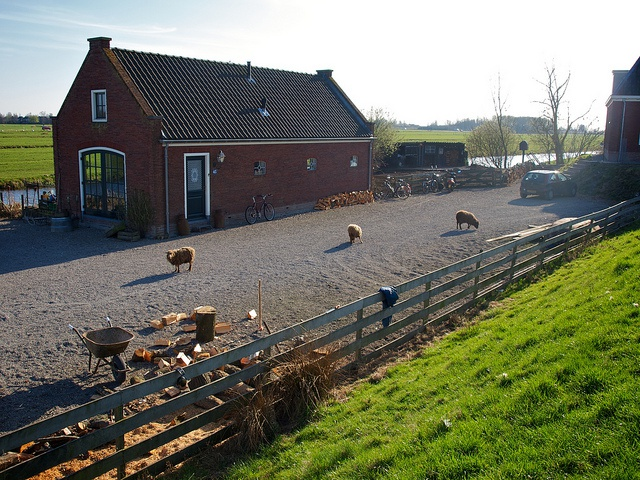Describe the objects in this image and their specific colors. I can see car in lightblue, gray, blue, and darkgray tones, bicycle in lightblue, black, gray, and darkblue tones, sheep in lightblue, black, gray, and maroon tones, bicycle in lightblue, gray, black, and darkgray tones, and sheep in lightblue, black, gray, and darkgray tones in this image. 